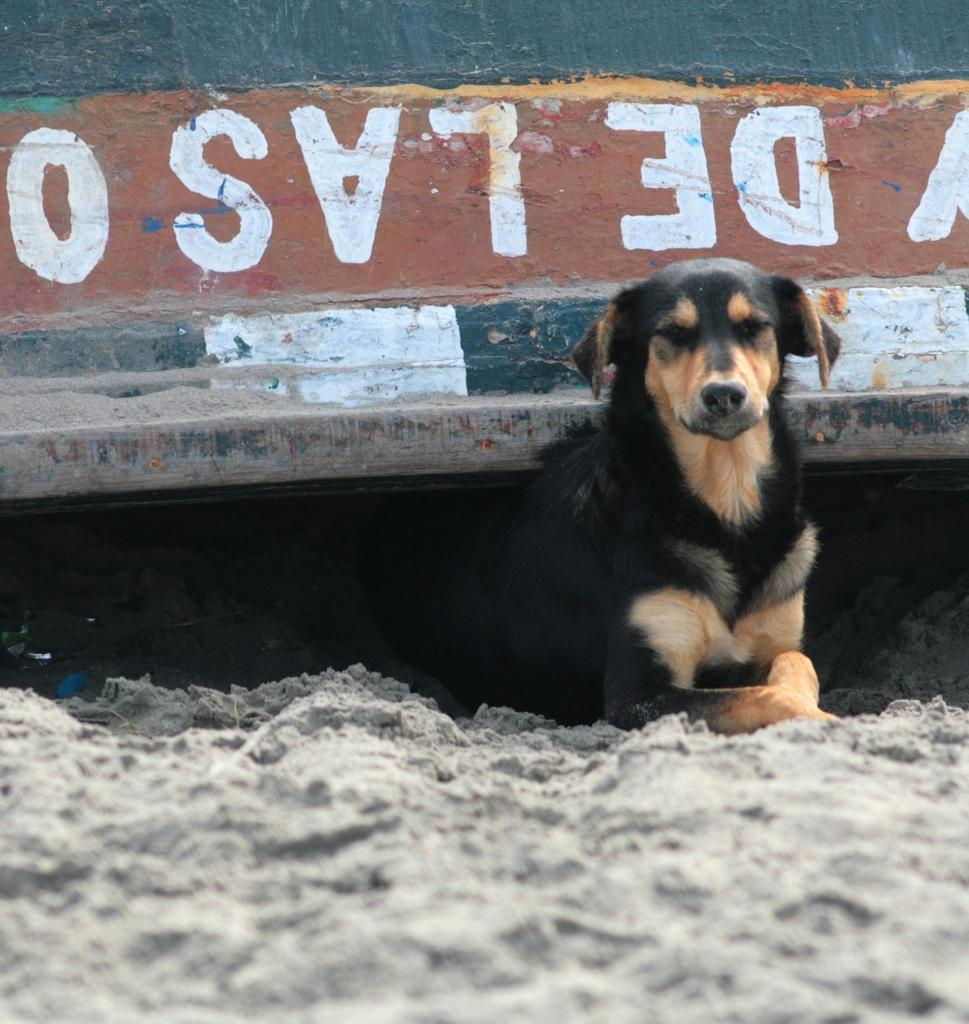What animal can be seen in the image? There is a dog in the image. Where is the dog located? The dog is sitting on the sand. What historical event is depicted by the sign in the image? There is no sign present in the image, so it is not possible to answer that question. 